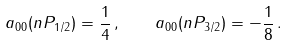<formula> <loc_0><loc_0><loc_500><loc_500>a _ { 0 0 } ( n P _ { 1 / 2 } ) = \frac { 1 } { 4 } \, , \quad a _ { 0 0 } ( n P _ { 3 / 2 } ) = - \frac { 1 } { 8 } \, .</formula> 